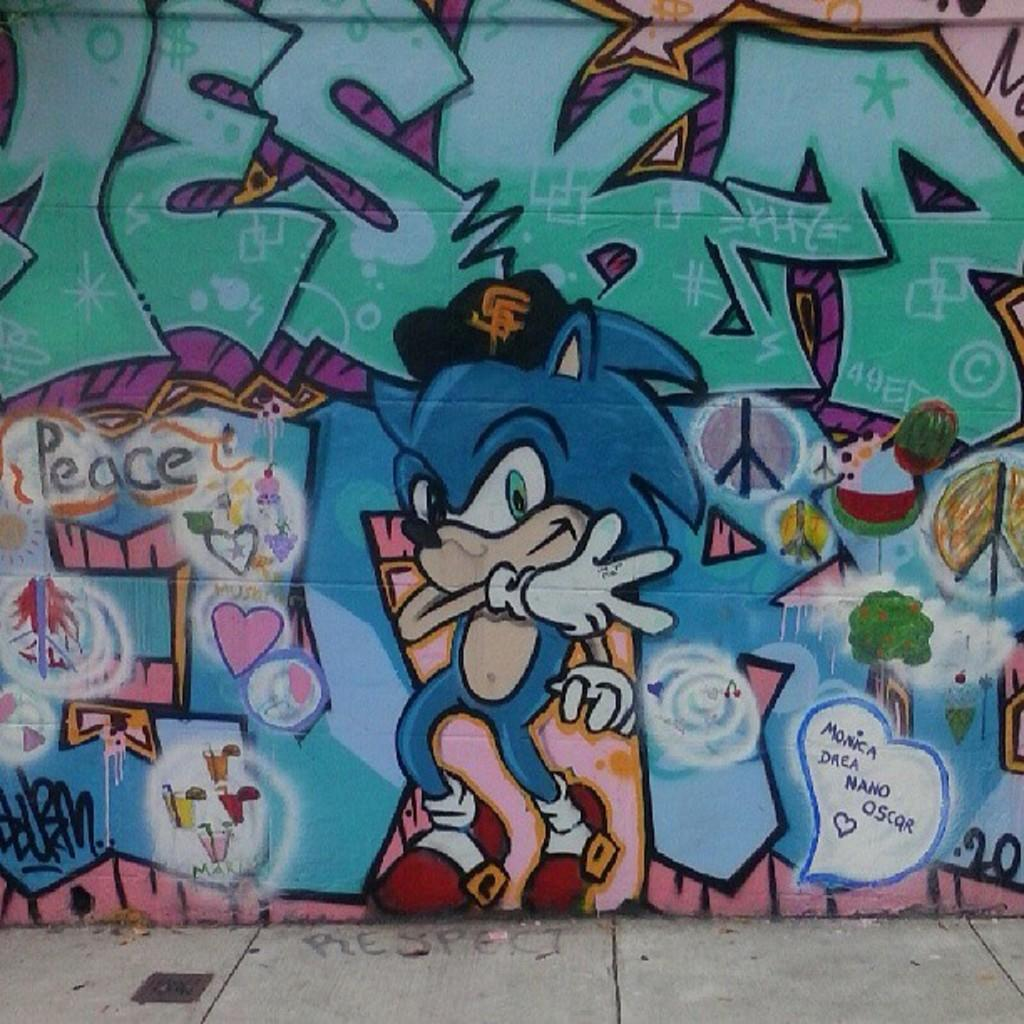What is depicted on the wall in the image? There is a painting on the wall in the image. What else can be seen in the image besides the painting? There is some text visible in the image. Can you hear the sound of thunder in the image? There is no sound, including thunder, present in the image, as it is a static visual representation. 